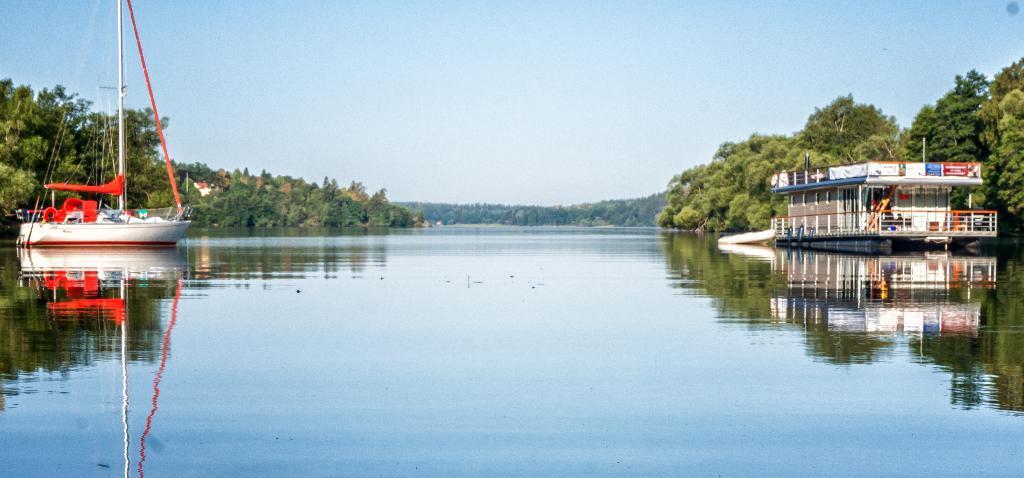Could you give a brief overview of what you see in this image? On the left and right side of the image we can see boats. In the background of the image we can see trees. At the top of the image there is a sky. At the bottom of the image there is a water. 